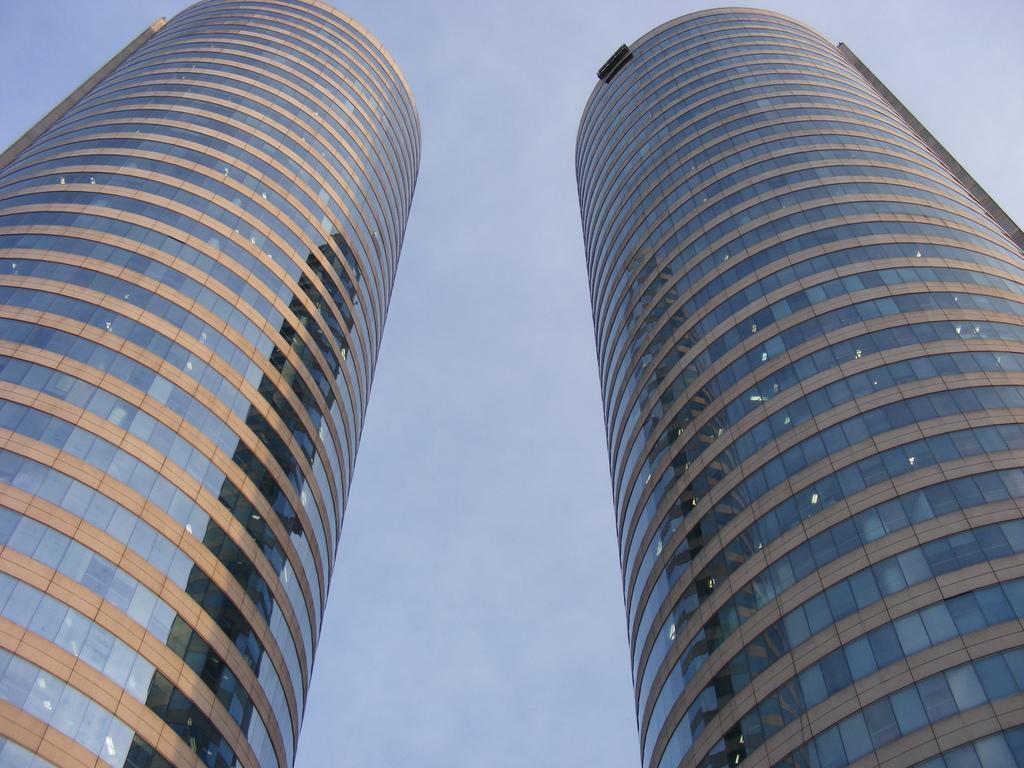Describe this image in one or two sentences. In this image, we can see buildings. In the background, we can see the sky. 